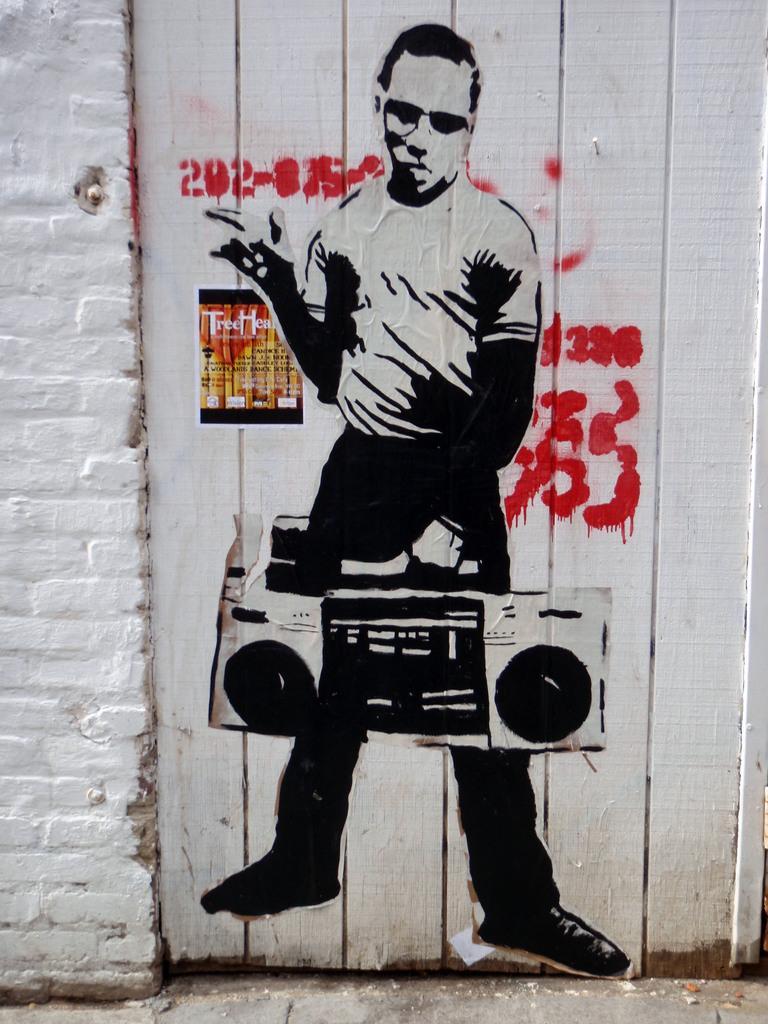Can you describe this image briefly? As we can see in the image there is a wall. On wall there is painting of a man holding tape recorder. 